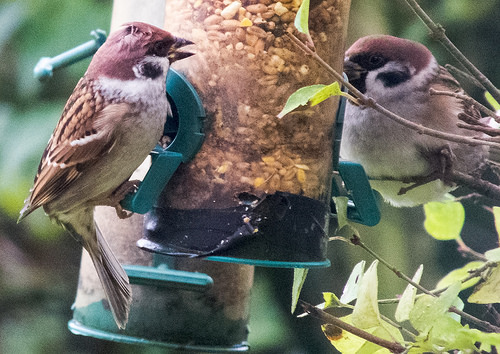<image>
Can you confirm if the leaf is behind the bird? No. The leaf is not behind the bird. From this viewpoint, the leaf appears to be positioned elsewhere in the scene. 